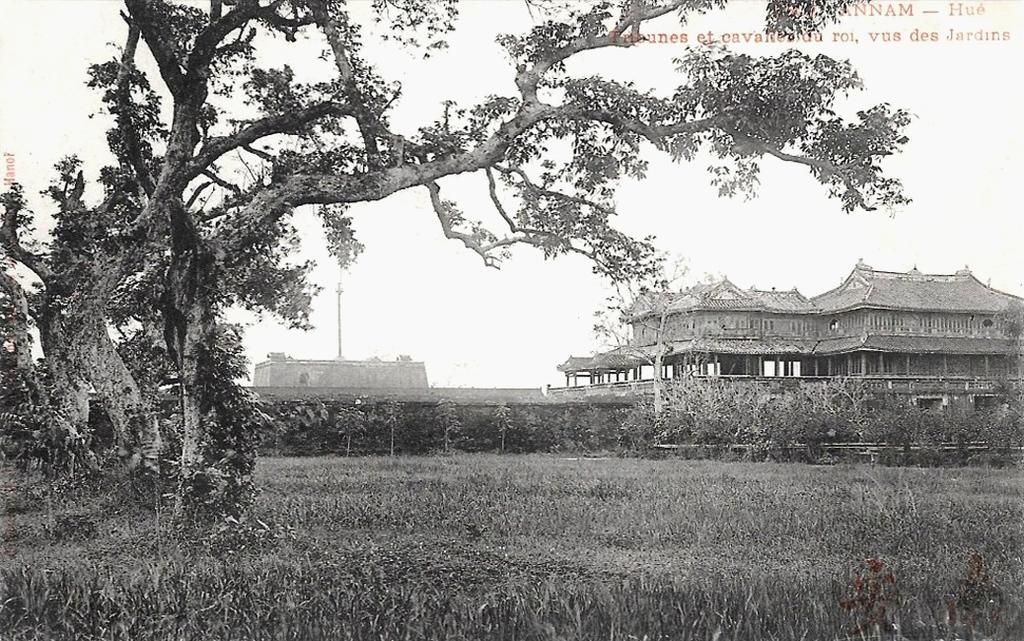How would you summarize this image in a sentence or two? This is a black and white picture. In this picture we can see the sky, buildings, pole, plants, trees and the field. Far it seems like the fence. 